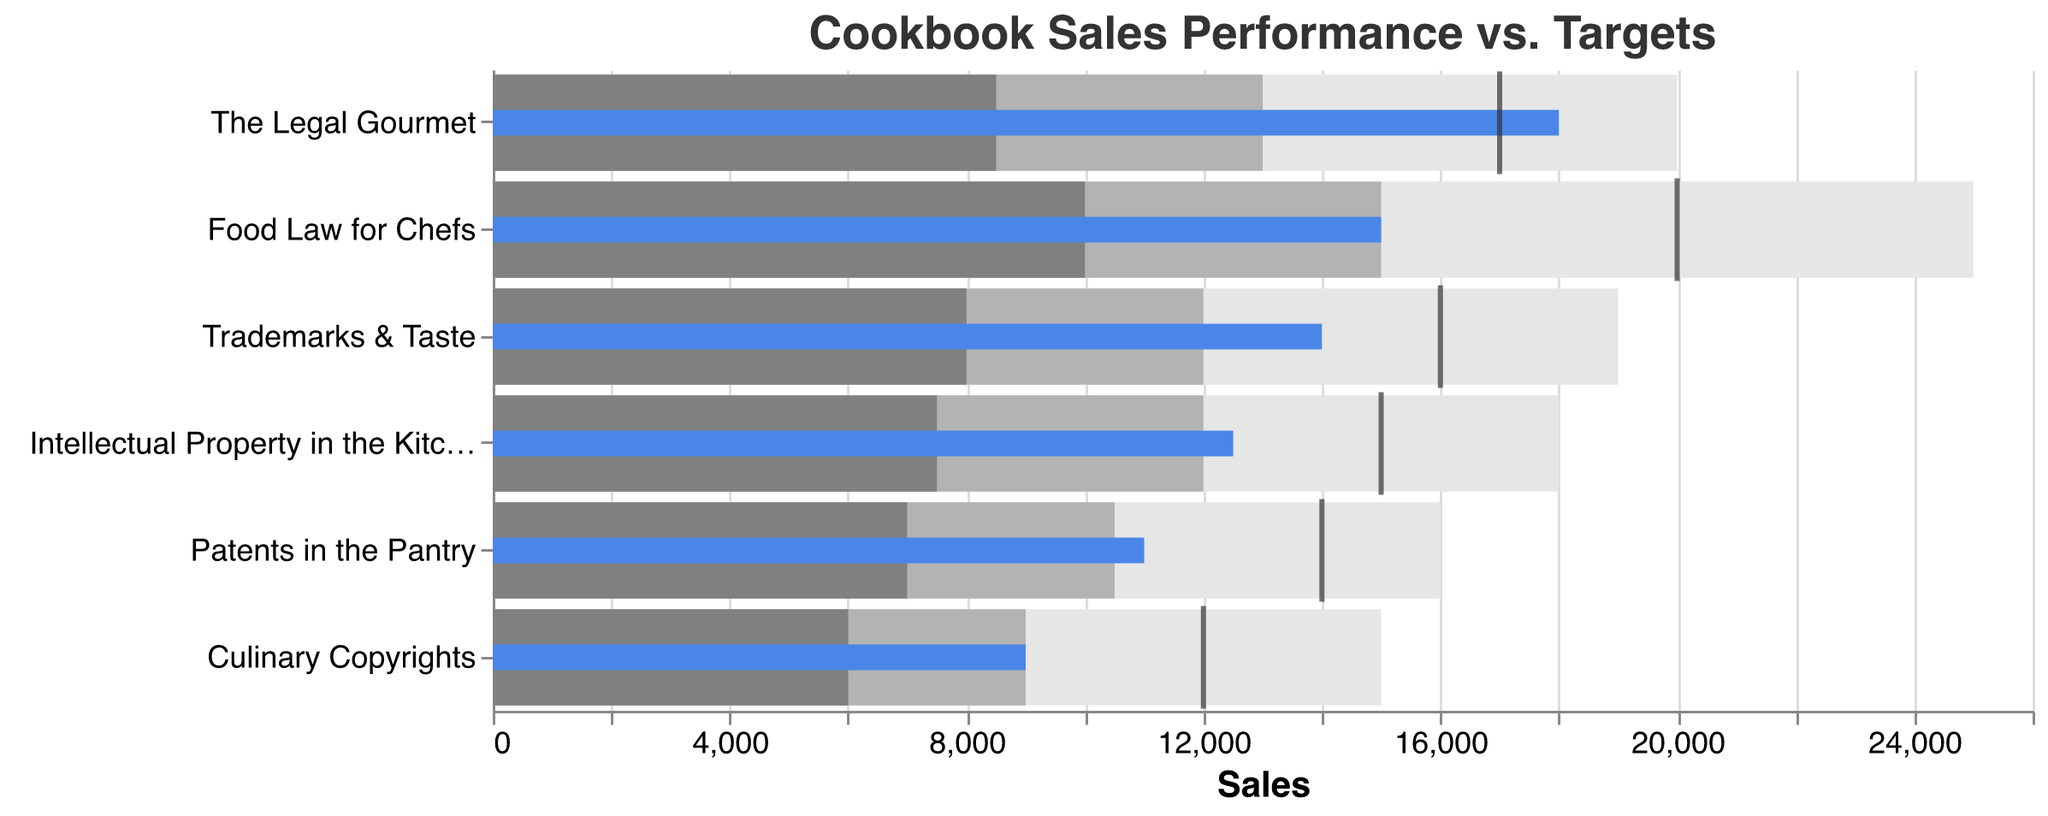What is the title of the figure? The title of the figure can be seen at the top of the chart.
Answer: Cookbook Sales Performance vs. Targets Which cookbook has the highest actual sales? By looking at the bar marked in blue that extends the farthest to the right, you can see "The Legal Gourmet" has the highest actual sales.
Answer: The Legal Gourmet Which cookbook's actual sales exceeded its target sales? Actual sales are represented by the blue bar, while the target is indicated by the black tick mark. Only "The Legal Gourmet" has its blue bar extending beyond the black tick mark.
Answer: The Legal Gourmet What are the excellent sales thresholds for "Food Law for Chefs" and "Trademarks & Taste"? The excellent sales thresholds are noted at the far right of the gray bars. For "Food Law for Chefs," it is 25,000, and for "Trademarks & Taste," it is 19,000.
Answer: 25,000 and 19,000 How do "Intellectual Property in the Kitchen" and "Culinary Copyrights" compare regarding their actual sales? "Intellectual Property in the Kitchen" has an actual sales value of 12,500, while "Culinary Copyrights" has an actual sales value of 9,000. 12,500 - 9,000 = 3,500.
Answer: 3,500 Which cookbooks did not meet their target sales but still performed within satisfactory limits? Examine the blue bars in relation to the black tick marks and the gray bars marked "Satisfactory." "Food Law for Chefs," "Intellectual Property in the Kitchen," "Trademarks & Taste," and "Patents in the Pantry" have blue bars within the satisfactory range but do not reach their target.
Answer: Food Law for Chefs, Intellectual Property in the Kitchen, Trademarks & Taste, Patents in the Pantry What is the target sales value for "Patents in the Pantry," and how does it compare to its actual sales? The target sales value is indicated by the black tick mark. For "Patents in the Pantry," it is 14,000, while the actual sales are indicated by the blue bar, which is 11,000. 14,000 - 11,000 = 3,000.
Answer: 14,000; 3,000 Which book has its actual sales equal to the good performance threshold? By comparing the endpoints of the blue bars and the gray bars marked "Good," we see that "Culinary Copyrights" has its actual sales equal to the good performance threshold of 9,000.
Answer: Culinary Copyrights Between "Food Law for Chefs" and "Trademarks & Taste," which one has a closer actual sales value to its target? "Food Law for Chefs" has actual sales of 15,000 and a target of 20,000, which is a difference of 5,000. "Trademarks & Taste" has actual sales of 14,000 and a target of 16,000, which is a difference of 2,000. Therefore, "Trademarks & Taste" is closer to its target.
Answer: Trademarks & Taste How many books achieved excellent sales performance? Excellent sales performance is noted by the farthest right segment of the gray bars. None of the blue bars (actual sales) extend into the excellent performance segment.
Answer: None 